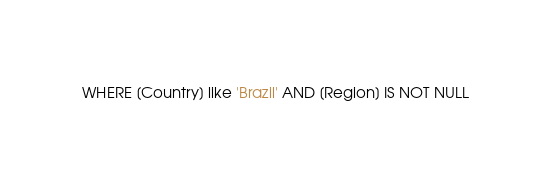Convert code to text. <code><loc_0><loc_0><loc_500><loc_500><_SQL_>WHERE [Country] like 'Brazil' AND [Region] IS NOT NULL</code> 